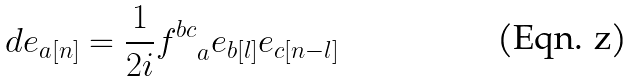<formula> <loc_0><loc_0><loc_500><loc_500>d e _ { a [ n ] } = \frac { 1 } { 2 i } { f ^ { b c } } _ { a } e _ { b [ l ] } e _ { c [ n - l ] }</formula> 